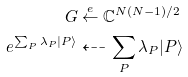Convert formula to latex. <formula><loc_0><loc_0><loc_500><loc_500>G & \stackrel { e } { \leftarrow } \mathbb { C } ^ { N ( N - 1 ) / 2 } \\ e ^ { \sum _ { P } \lambda _ { P } | P \rangle } & \dashleftarrow \sum _ { P } \lambda _ { P } | P \rangle</formula> 